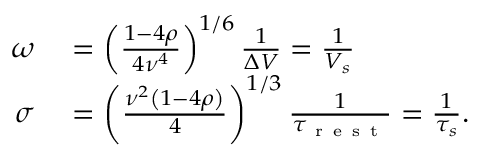<formula> <loc_0><loc_0><loc_500><loc_500>\begin{array} { r l } { \omega } & = \left ( \frac { 1 - 4 \rho } { 4 \nu ^ { 4 } } \right ) ^ { 1 / 6 } \frac { 1 } { \Delta V } = \frac { 1 } { V _ { s } } } \\ { \sigma } & = \left ( \frac { \nu ^ { 2 } \left ( 1 - 4 \rho \right ) } { 4 } \right ) ^ { 1 / 3 } \frac { 1 } { \tau _ { r e s t } } = \frac { 1 } { \tau _ { s } } . } \end{array}</formula> 